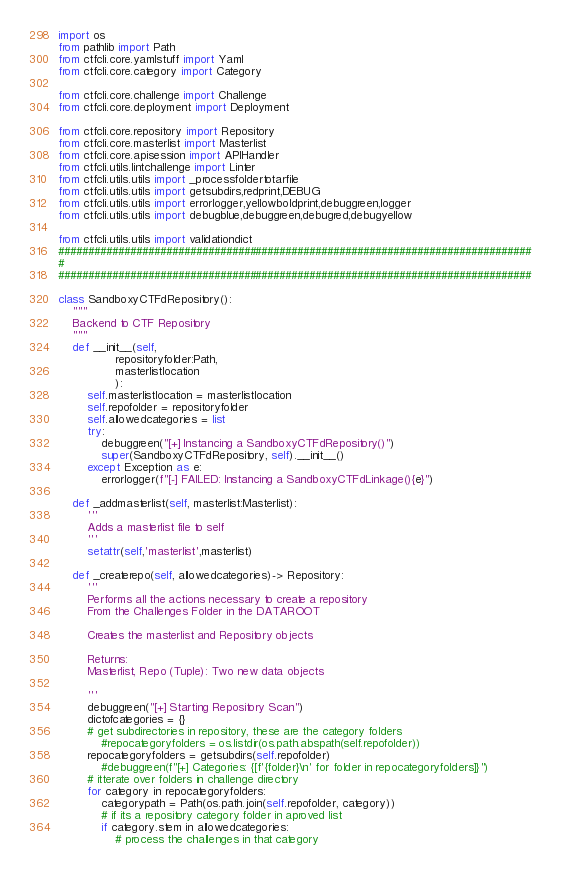<code> <loc_0><loc_0><loc_500><loc_500><_Python_>import os
from pathlib import Path
from ctfcli.core.yamlstuff import Yaml
from ctfcli.core.category import Category

from ctfcli.core.challenge import Challenge
from ctfcli.core.deployment import Deployment

from ctfcli.core.repository import Repository
from ctfcli.core.masterlist import Masterlist
from ctfcli.core.apisession import APIHandler
from ctfcli.utils.lintchallenge import Linter
from ctfcli.utils.utils import _processfoldertotarfile
from ctfcli.utils.utils import getsubdirs,redprint,DEBUG
from ctfcli.utils.utils import errorlogger,yellowboldprint,debuggreen,logger
from ctfcli.utils.utils import debugblue,debuggreen,debugred,debugyellow

from ctfcli.utils.utils import validationdict
###############################################################################
#
###############################################################################

class SandboxyCTFdRepository():
    """
    Backend to CTF Repository
    """
    def __init__(self,
                repositoryfolder:Path,
                masterlistlocation
                ):
        self.masterlistlocation = masterlistlocation
        self.repofolder = repositoryfolder
        self.allowedcategories = list
        try:
            debuggreen("[+] Instancing a SandboxyCTFdRepository()")
            super(SandboxyCTFdRepository, self).__init__()
        except Exception as e:
            errorlogger(f"[-] FAILED: Instancing a SandboxyCTFdLinkage(){e}")

    def _addmasterlist(self, masterlist:Masterlist):
        '''
        Adds a masterlist file to self
        '''
        setattr(self,'masterlist',masterlist)
        
    def _createrepo(self, allowedcategories)-> Repository:
        '''
        Performs all the actions necessary to create a repository
        From the Challenges Folder in the DATAROOT

        Creates the masterlist and Repository objects

        Returns:
        Masterlist, Repo (Tuple): Two new data objects

        '''
        debuggreen("[+] Starting Repository Scan")
        dictofcategories = {}
        # get subdirectories in repository, these are the category folders
            #repocategoryfolders = os.listdir(os.path.abspath(self.repofolder))
        repocategoryfolders = getsubdirs(self.repofolder)
            #debuggreen(f"[+] Categories: {[f'{folder}\n' for folder in repocategoryfolders]}")
        # itterate over folders in challenge directory
        for category in repocategoryfolders:
            categorypath = Path(os.path.join(self.repofolder, category))
            # if its a repository category folder in aproved list
            if category.stem in allowedcategories:
                # process the challenges in that category</code> 